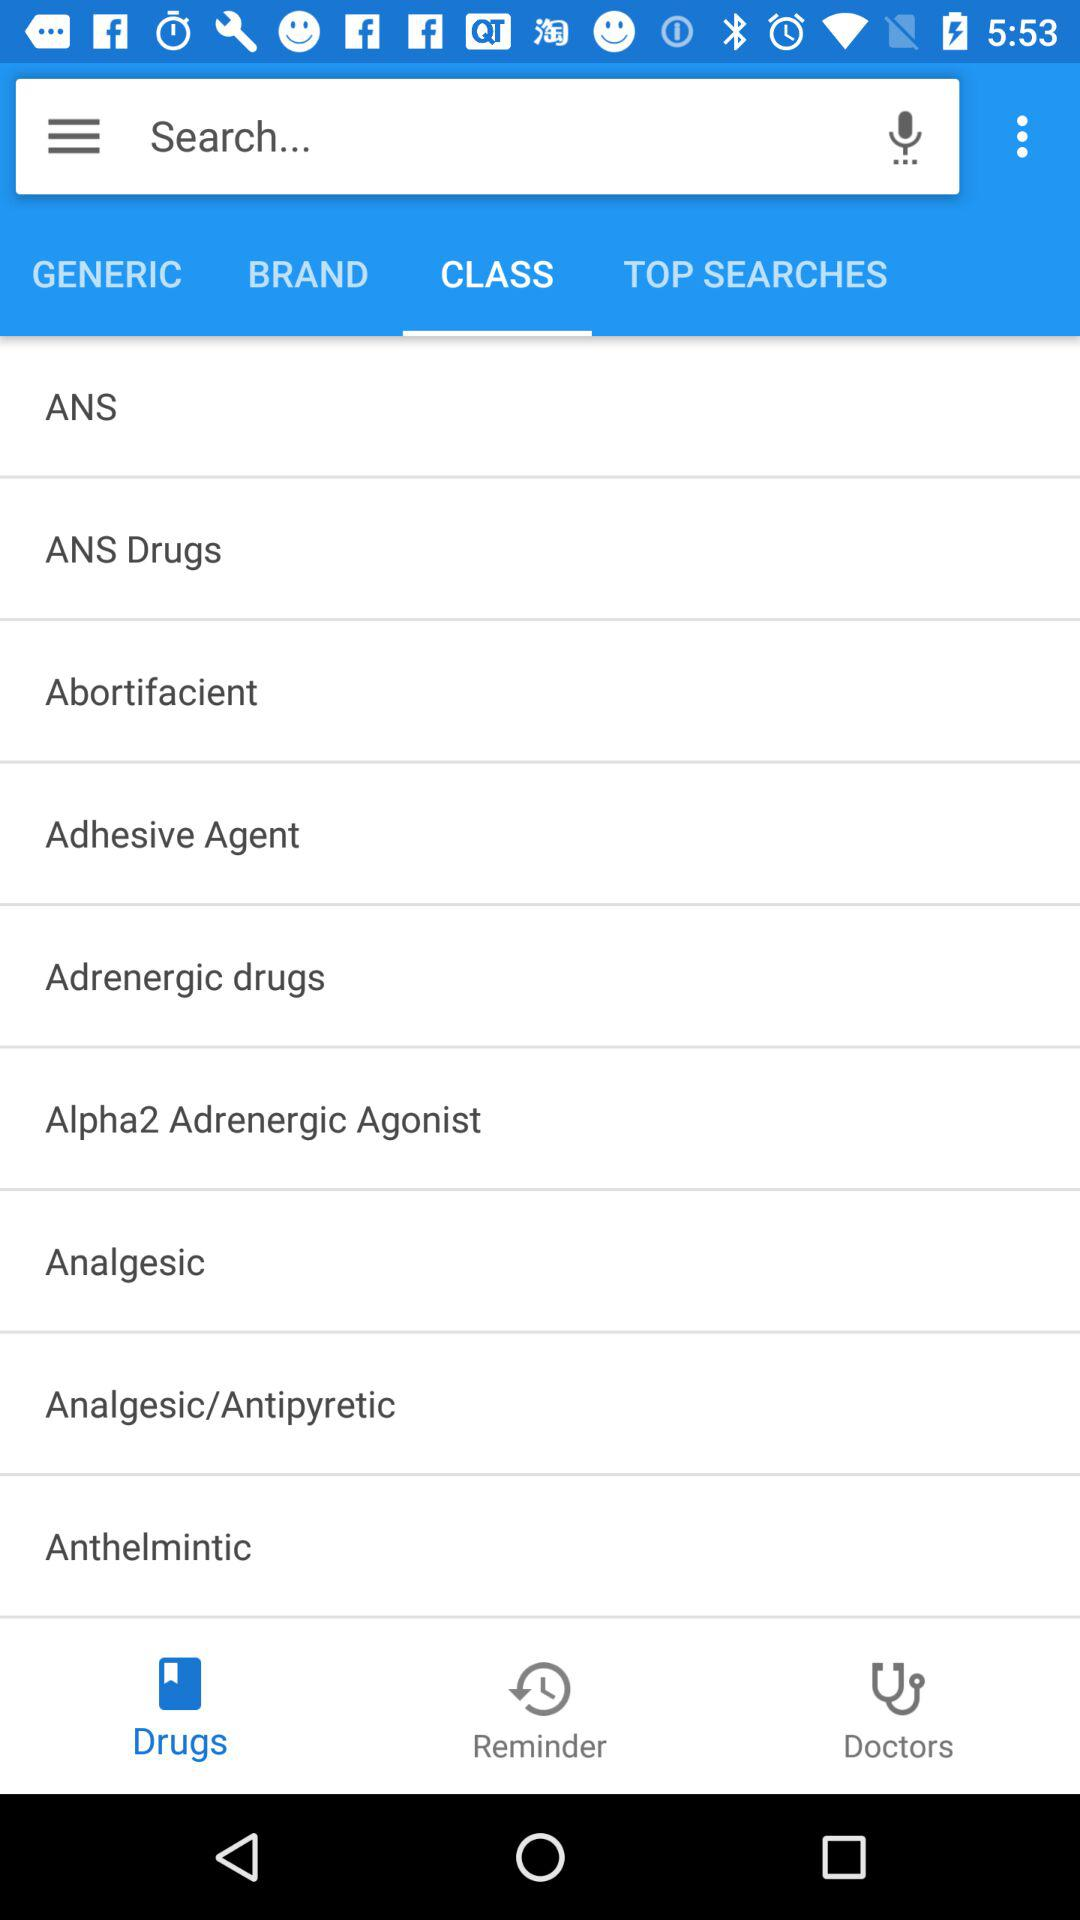What is the selected tab in drugs? The selected tab in drugs is class. 